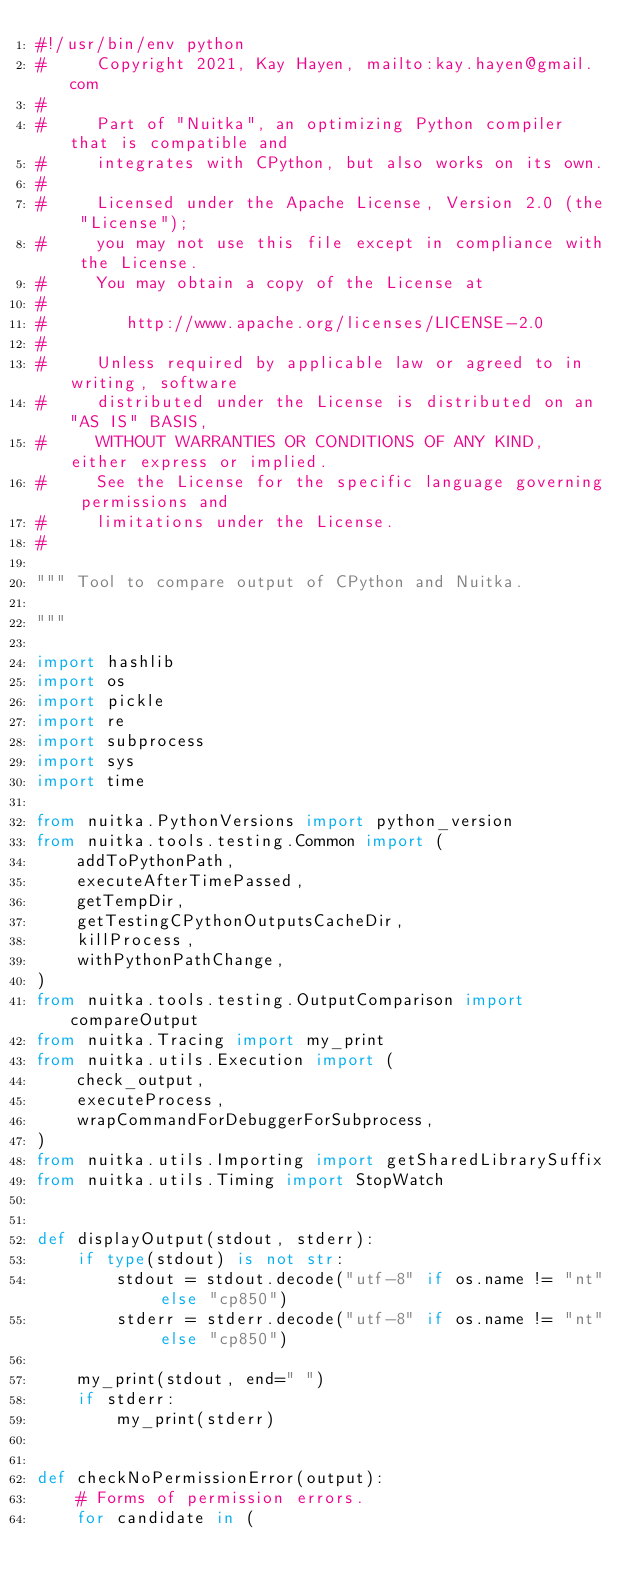Convert code to text. <code><loc_0><loc_0><loc_500><loc_500><_Python_>#!/usr/bin/env python
#     Copyright 2021, Kay Hayen, mailto:kay.hayen@gmail.com
#
#     Part of "Nuitka", an optimizing Python compiler that is compatible and
#     integrates with CPython, but also works on its own.
#
#     Licensed under the Apache License, Version 2.0 (the "License");
#     you may not use this file except in compliance with the License.
#     You may obtain a copy of the License at
#
#        http://www.apache.org/licenses/LICENSE-2.0
#
#     Unless required by applicable law or agreed to in writing, software
#     distributed under the License is distributed on an "AS IS" BASIS,
#     WITHOUT WARRANTIES OR CONDITIONS OF ANY KIND, either express or implied.
#     See the License for the specific language governing permissions and
#     limitations under the License.
#

""" Tool to compare output of CPython and Nuitka.

"""

import hashlib
import os
import pickle
import re
import subprocess
import sys
import time

from nuitka.PythonVersions import python_version
from nuitka.tools.testing.Common import (
    addToPythonPath,
    executeAfterTimePassed,
    getTempDir,
    getTestingCPythonOutputsCacheDir,
    killProcess,
    withPythonPathChange,
)
from nuitka.tools.testing.OutputComparison import compareOutput
from nuitka.Tracing import my_print
from nuitka.utils.Execution import (
    check_output,
    executeProcess,
    wrapCommandForDebuggerForSubprocess,
)
from nuitka.utils.Importing import getSharedLibrarySuffix
from nuitka.utils.Timing import StopWatch


def displayOutput(stdout, stderr):
    if type(stdout) is not str:
        stdout = stdout.decode("utf-8" if os.name != "nt" else "cp850")
        stderr = stderr.decode("utf-8" if os.name != "nt" else "cp850")

    my_print(stdout, end=" ")
    if stderr:
        my_print(stderr)


def checkNoPermissionError(output):
    # Forms of permission errors.
    for candidate in (</code> 